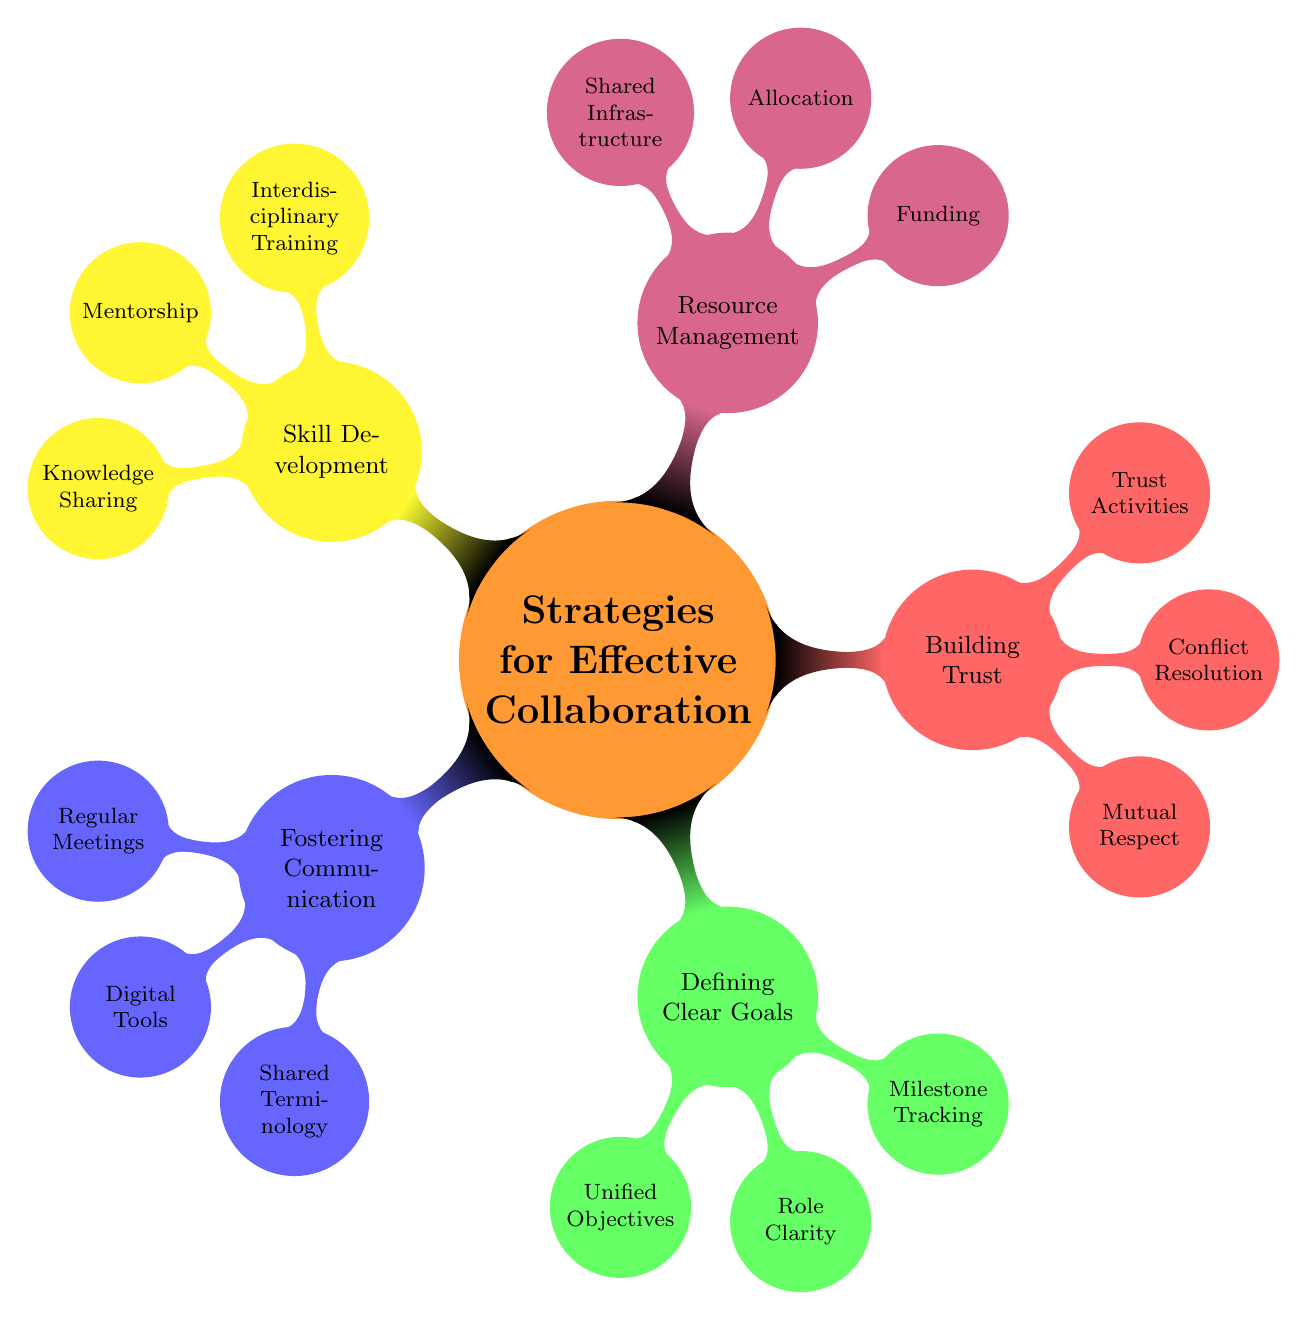What are the main strategies for collaboration? The mind map outlines five main strategies for effective collaboration: Fostering Communication, Defining Clear Goals, Building Trust and Respect, Resource Management, and Skill Development.
Answer: Fostering Communication, Defining Clear Goals, Building Trust and Respect, Resource Management, Skill Development How many nodes are under 'Building Trust'? Under the 'Building Trust and Respect' node, there are three sub-nodes: Mutual Respect, Conflict Resolution, and Trust-Building Activities.
Answer: 3 What tool is suggested for milestone tracking? According to the diagram, tools suggested for milestone tracking include Gantt Charts and Progress Dashboards.
Answer: Gantt Charts, Progress Dashboards Which strategy includes 'Shared Terminology'? 'Shared Terminology' is a sub-node under the 'Fostering Communication' strategy.
Answer: Fostering Communication Which type of training is included in Skill Development? The diagram lists Interdisciplinary Training as a type of program under Skill Development.
Answer: Interdisciplinary Training What kind of activities are recommended for building trust? The trust-building activities include team-building exercises and social events as listed under the 'Trust-Building Activities' node.
Answer: Team-building exercises, social events What are the two sources of funding opportunities mentioned? The mind map identifies the National Institutes of Health and the National Science Foundation as funding sources under Resource Management.
Answer: National Institutes of Health, National Science Foundation Which strategy has the fewest sub-nodes? 'Resource Management' has the fewest sub-nodes with three entries: Funding Opportunities, Resource Allocation, and Shared Infrastructure.
Answer: Resource Management What does 'Role Clarity' refer to in the diagram? 'Role Clarity' refers to defining the responsibilities of each collaborator under the 'Defining Clear Goals' strategy.
Answer: Defining the responsibilities of each collaborator 